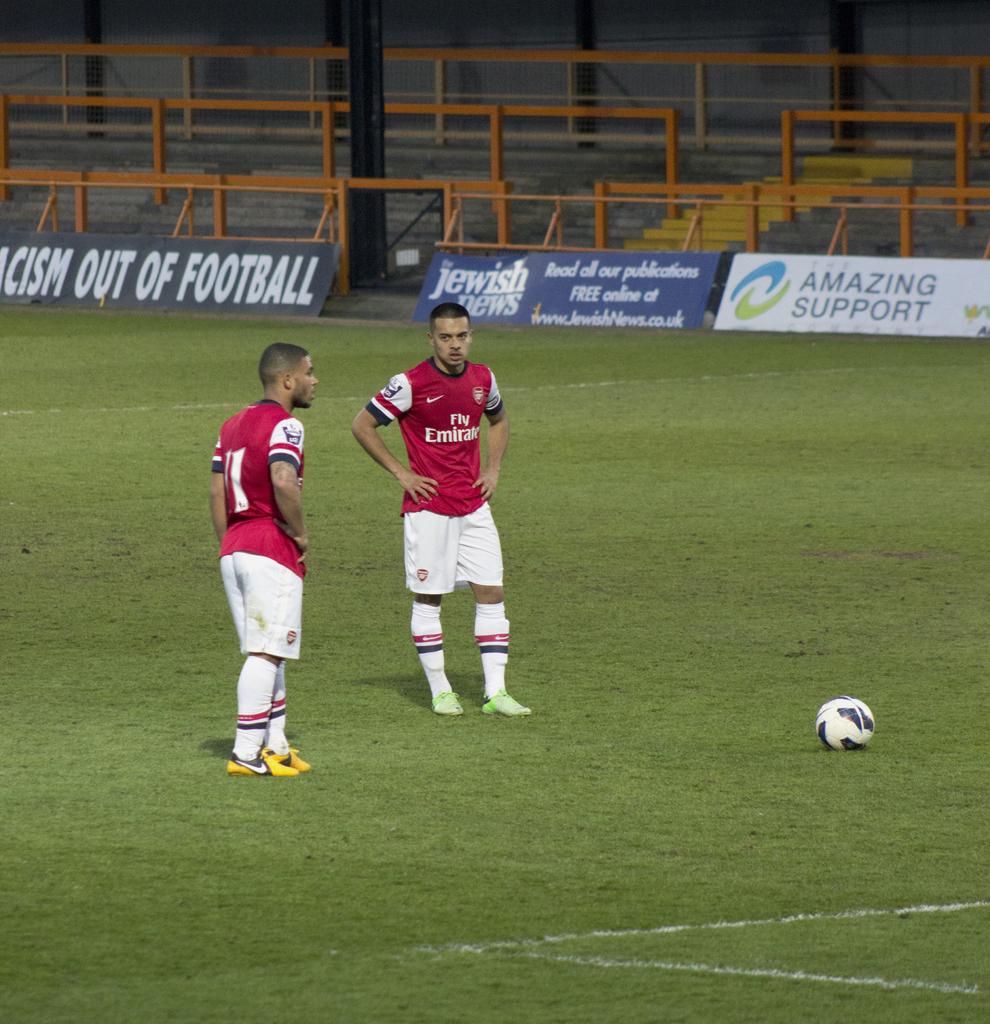What kind of support is shown?
Make the answer very short. Amazing. What is on the white, back banner?
Offer a terse response. Amazing support. 